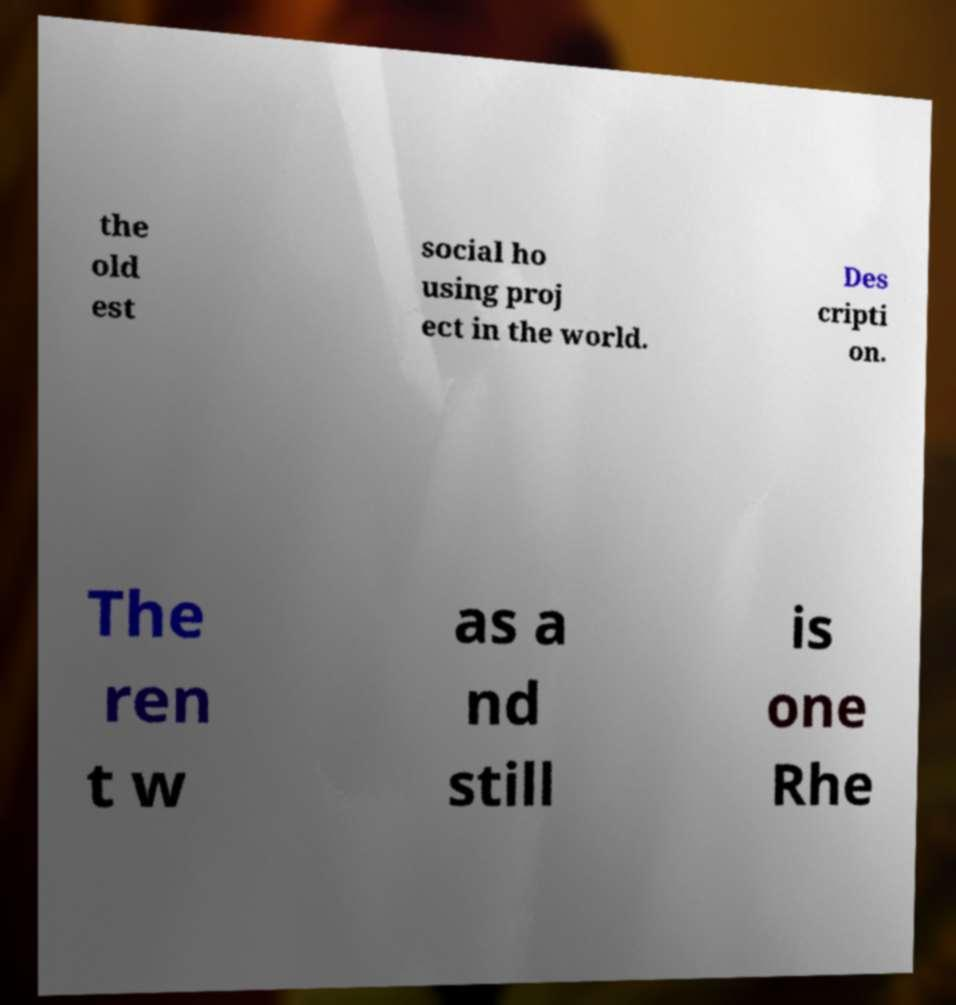Could you extract and type out the text from this image? the old est social ho using proj ect in the world. Des cripti on. The ren t w as a nd still is one Rhe 